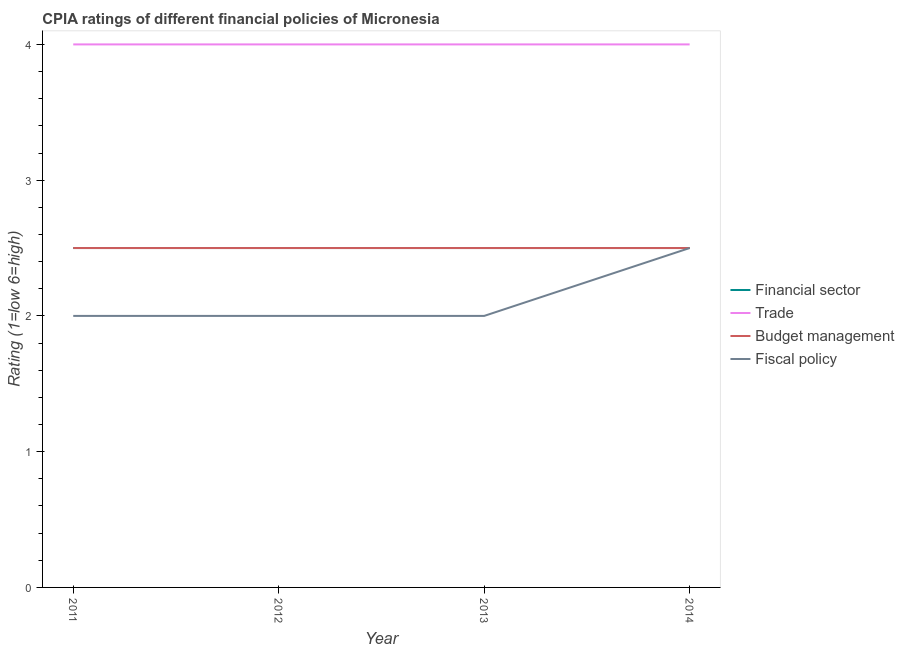How many different coloured lines are there?
Give a very brief answer. 4. Does the line corresponding to cpia rating of budget management intersect with the line corresponding to cpia rating of financial sector?
Your answer should be compact. Yes. In which year was the cpia rating of budget management minimum?
Provide a succinct answer. 2011. What is the average cpia rating of fiscal policy per year?
Offer a terse response. 2.12. In the year 2014, what is the difference between the cpia rating of trade and cpia rating of financial sector?
Your answer should be compact. 1.5. In how many years, is the cpia rating of trade greater than 0.8?
Give a very brief answer. 4. Is the cpia rating of budget management in 2011 less than that in 2013?
Your response must be concise. No. What is the difference between the highest and the second highest cpia rating of fiscal policy?
Ensure brevity in your answer.  0.5. Is it the case that in every year, the sum of the cpia rating of financial sector and cpia rating of trade is greater than the cpia rating of budget management?
Provide a short and direct response. Yes. Is the cpia rating of trade strictly greater than the cpia rating of financial sector over the years?
Provide a short and direct response. Yes. Is the cpia rating of financial sector strictly less than the cpia rating of fiscal policy over the years?
Make the answer very short. No. How many legend labels are there?
Offer a terse response. 4. What is the title of the graph?
Your answer should be compact. CPIA ratings of different financial policies of Micronesia. What is the label or title of the Y-axis?
Give a very brief answer. Rating (1=low 6=high). What is the Rating (1=low 6=high) in Budget management in 2011?
Your answer should be compact. 2.5. What is the Rating (1=low 6=high) in Trade in 2012?
Your answer should be very brief. 4. What is the Rating (1=low 6=high) of Fiscal policy in 2012?
Keep it short and to the point. 2. What is the Rating (1=low 6=high) of Trade in 2013?
Make the answer very short. 4. What is the Rating (1=low 6=high) in Trade in 2014?
Offer a very short reply. 4. What is the Rating (1=low 6=high) of Budget management in 2014?
Ensure brevity in your answer.  2.5. What is the Rating (1=low 6=high) of Fiscal policy in 2014?
Provide a succinct answer. 2.5. Across all years, what is the maximum Rating (1=low 6=high) of Financial sector?
Provide a short and direct response. 2.5. Across all years, what is the maximum Rating (1=low 6=high) of Budget management?
Offer a very short reply. 2.5. Across all years, what is the minimum Rating (1=low 6=high) of Fiscal policy?
Make the answer very short. 2. What is the total Rating (1=low 6=high) of Financial sector in the graph?
Make the answer very short. 10. What is the total Rating (1=low 6=high) of Budget management in the graph?
Offer a very short reply. 10. What is the total Rating (1=low 6=high) in Fiscal policy in the graph?
Provide a succinct answer. 8.5. What is the difference between the Rating (1=low 6=high) of Financial sector in 2011 and that in 2012?
Offer a very short reply. 0. What is the difference between the Rating (1=low 6=high) of Trade in 2011 and that in 2012?
Provide a succinct answer. 0. What is the difference between the Rating (1=low 6=high) in Financial sector in 2012 and that in 2013?
Provide a short and direct response. 0. What is the difference between the Rating (1=low 6=high) in Fiscal policy in 2012 and that in 2013?
Your answer should be very brief. 0. What is the difference between the Rating (1=low 6=high) in Financial sector in 2012 and that in 2014?
Your response must be concise. 0. What is the difference between the Rating (1=low 6=high) of Fiscal policy in 2012 and that in 2014?
Give a very brief answer. -0.5. What is the difference between the Rating (1=low 6=high) of Financial sector in 2013 and that in 2014?
Your answer should be very brief. 0. What is the difference between the Rating (1=low 6=high) in Trade in 2013 and that in 2014?
Your answer should be compact. 0. What is the difference between the Rating (1=low 6=high) of Budget management in 2013 and that in 2014?
Provide a short and direct response. 0. What is the difference between the Rating (1=low 6=high) in Fiscal policy in 2013 and that in 2014?
Provide a succinct answer. -0.5. What is the difference between the Rating (1=low 6=high) in Financial sector in 2011 and the Rating (1=low 6=high) in Trade in 2012?
Provide a short and direct response. -1.5. What is the difference between the Rating (1=low 6=high) of Financial sector in 2011 and the Rating (1=low 6=high) of Fiscal policy in 2012?
Provide a short and direct response. 0.5. What is the difference between the Rating (1=low 6=high) in Trade in 2011 and the Rating (1=low 6=high) in Budget management in 2012?
Offer a terse response. 1.5. What is the difference between the Rating (1=low 6=high) in Budget management in 2011 and the Rating (1=low 6=high) in Fiscal policy in 2012?
Your answer should be very brief. 0.5. What is the difference between the Rating (1=low 6=high) of Financial sector in 2011 and the Rating (1=low 6=high) of Trade in 2013?
Your response must be concise. -1.5. What is the difference between the Rating (1=low 6=high) of Trade in 2011 and the Rating (1=low 6=high) of Budget management in 2013?
Offer a very short reply. 1.5. What is the difference between the Rating (1=low 6=high) of Trade in 2011 and the Rating (1=low 6=high) of Fiscal policy in 2013?
Keep it short and to the point. 2. What is the difference between the Rating (1=low 6=high) of Budget management in 2011 and the Rating (1=low 6=high) of Fiscal policy in 2013?
Ensure brevity in your answer.  0.5. What is the difference between the Rating (1=low 6=high) in Trade in 2011 and the Rating (1=low 6=high) in Budget management in 2014?
Give a very brief answer. 1.5. What is the difference between the Rating (1=low 6=high) of Budget management in 2011 and the Rating (1=low 6=high) of Fiscal policy in 2014?
Provide a succinct answer. 0. What is the difference between the Rating (1=low 6=high) of Trade in 2012 and the Rating (1=low 6=high) of Budget management in 2013?
Your response must be concise. 1.5. What is the difference between the Rating (1=low 6=high) in Trade in 2012 and the Rating (1=low 6=high) in Fiscal policy in 2013?
Offer a very short reply. 2. What is the difference between the Rating (1=low 6=high) of Financial sector in 2012 and the Rating (1=low 6=high) of Budget management in 2014?
Your answer should be very brief. 0. What is the difference between the Rating (1=low 6=high) in Trade in 2012 and the Rating (1=low 6=high) in Budget management in 2014?
Provide a short and direct response. 1.5. What is the difference between the Rating (1=low 6=high) of Budget management in 2012 and the Rating (1=low 6=high) of Fiscal policy in 2014?
Offer a terse response. 0. What is the difference between the Rating (1=low 6=high) of Financial sector in 2013 and the Rating (1=low 6=high) of Trade in 2014?
Your response must be concise. -1.5. What is the difference between the Rating (1=low 6=high) in Financial sector in 2013 and the Rating (1=low 6=high) in Budget management in 2014?
Keep it short and to the point. 0. What is the difference between the Rating (1=low 6=high) of Trade in 2013 and the Rating (1=low 6=high) of Budget management in 2014?
Provide a short and direct response. 1.5. What is the difference between the Rating (1=low 6=high) of Budget management in 2013 and the Rating (1=low 6=high) of Fiscal policy in 2014?
Ensure brevity in your answer.  0. What is the average Rating (1=low 6=high) in Financial sector per year?
Your answer should be compact. 2.5. What is the average Rating (1=low 6=high) in Trade per year?
Your answer should be very brief. 4. What is the average Rating (1=low 6=high) in Budget management per year?
Ensure brevity in your answer.  2.5. What is the average Rating (1=low 6=high) of Fiscal policy per year?
Offer a terse response. 2.12. In the year 2011, what is the difference between the Rating (1=low 6=high) in Financial sector and Rating (1=low 6=high) in Budget management?
Provide a short and direct response. 0. In the year 2011, what is the difference between the Rating (1=low 6=high) in Financial sector and Rating (1=low 6=high) in Fiscal policy?
Make the answer very short. 0.5. In the year 2011, what is the difference between the Rating (1=low 6=high) of Trade and Rating (1=low 6=high) of Budget management?
Your answer should be compact. 1.5. In the year 2012, what is the difference between the Rating (1=low 6=high) in Financial sector and Rating (1=low 6=high) in Trade?
Your response must be concise. -1.5. In the year 2012, what is the difference between the Rating (1=low 6=high) in Financial sector and Rating (1=low 6=high) in Fiscal policy?
Ensure brevity in your answer.  0.5. In the year 2012, what is the difference between the Rating (1=low 6=high) of Trade and Rating (1=low 6=high) of Fiscal policy?
Your response must be concise. 2. In the year 2013, what is the difference between the Rating (1=low 6=high) of Financial sector and Rating (1=low 6=high) of Fiscal policy?
Provide a succinct answer. 0.5. In the year 2013, what is the difference between the Rating (1=low 6=high) in Trade and Rating (1=low 6=high) in Fiscal policy?
Give a very brief answer. 2. In the year 2014, what is the difference between the Rating (1=low 6=high) of Financial sector and Rating (1=low 6=high) of Fiscal policy?
Offer a terse response. 0. In the year 2014, what is the difference between the Rating (1=low 6=high) in Trade and Rating (1=low 6=high) in Fiscal policy?
Provide a short and direct response. 1.5. What is the ratio of the Rating (1=low 6=high) in Financial sector in 2011 to that in 2012?
Your answer should be very brief. 1. What is the ratio of the Rating (1=low 6=high) in Trade in 2011 to that in 2012?
Keep it short and to the point. 1. What is the ratio of the Rating (1=low 6=high) in Budget management in 2011 to that in 2012?
Your answer should be compact. 1. What is the ratio of the Rating (1=low 6=high) in Fiscal policy in 2011 to that in 2012?
Your response must be concise. 1. What is the ratio of the Rating (1=low 6=high) of Budget management in 2011 to that in 2013?
Provide a short and direct response. 1. What is the ratio of the Rating (1=low 6=high) in Financial sector in 2011 to that in 2014?
Give a very brief answer. 1. What is the ratio of the Rating (1=low 6=high) of Fiscal policy in 2011 to that in 2014?
Give a very brief answer. 0.8. What is the ratio of the Rating (1=low 6=high) of Budget management in 2012 to that in 2013?
Ensure brevity in your answer.  1. What is the ratio of the Rating (1=low 6=high) of Fiscal policy in 2012 to that in 2013?
Offer a terse response. 1. What is the ratio of the Rating (1=low 6=high) of Financial sector in 2012 to that in 2014?
Your response must be concise. 1. What is the ratio of the Rating (1=low 6=high) in Budget management in 2012 to that in 2014?
Provide a short and direct response. 1. What is the ratio of the Rating (1=low 6=high) in Financial sector in 2013 to that in 2014?
Provide a short and direct response. 1. What is the ratio of the Rating (1=low 6=high) of Fiscal policy in 2013 to that in 2014?
Your response must be concise. 0.8. What is the difference between the highest and the second highest Rating (1=low 6=high) in Trade?
Your response must be concise. 0. What is the difference between the highest and the second highest Rating (1=low 6=high) of Budget management?
Ensure brevity in your answer.  0. What is the difference between the highest and the second highest Rating (1=low 6=high) of Fiscal policy?
Make the answer very short. 0.5. What is the difference between the highest and the lowest Rating (1=low 6=high) of Financial sector?
Offer a very short reply. 0. What is the difference between the highest and the lowest Rating (1=low 6=high) in Trade?
Provide a succinct answer. 0. What is the difference between the highest and the lowest Rating (1=low 6=high) in Fiscal policy?
Offer a terse response. 0.5. 